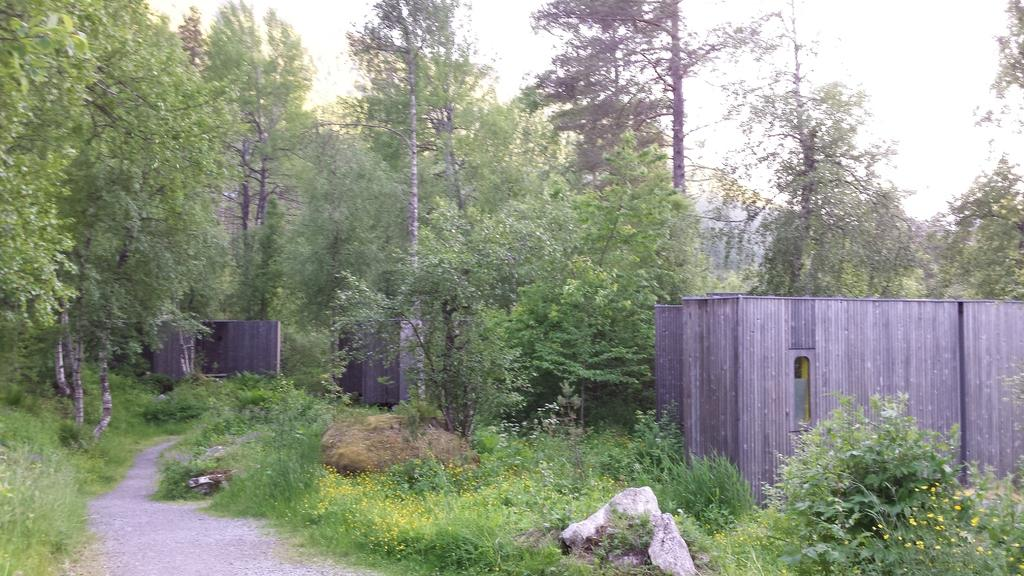What type of vegetation is present in the image? There are trees in the image. What is the color of the trees in the image? The trees are green in color. What other objects can be seen in the image besides the trees? There are stones and fencing visible in the image. What is the color of the sky in the background of the image? The sky in the background is white in color. What type of steel floor can be seen in the image? There is no steel floor present in the image. 